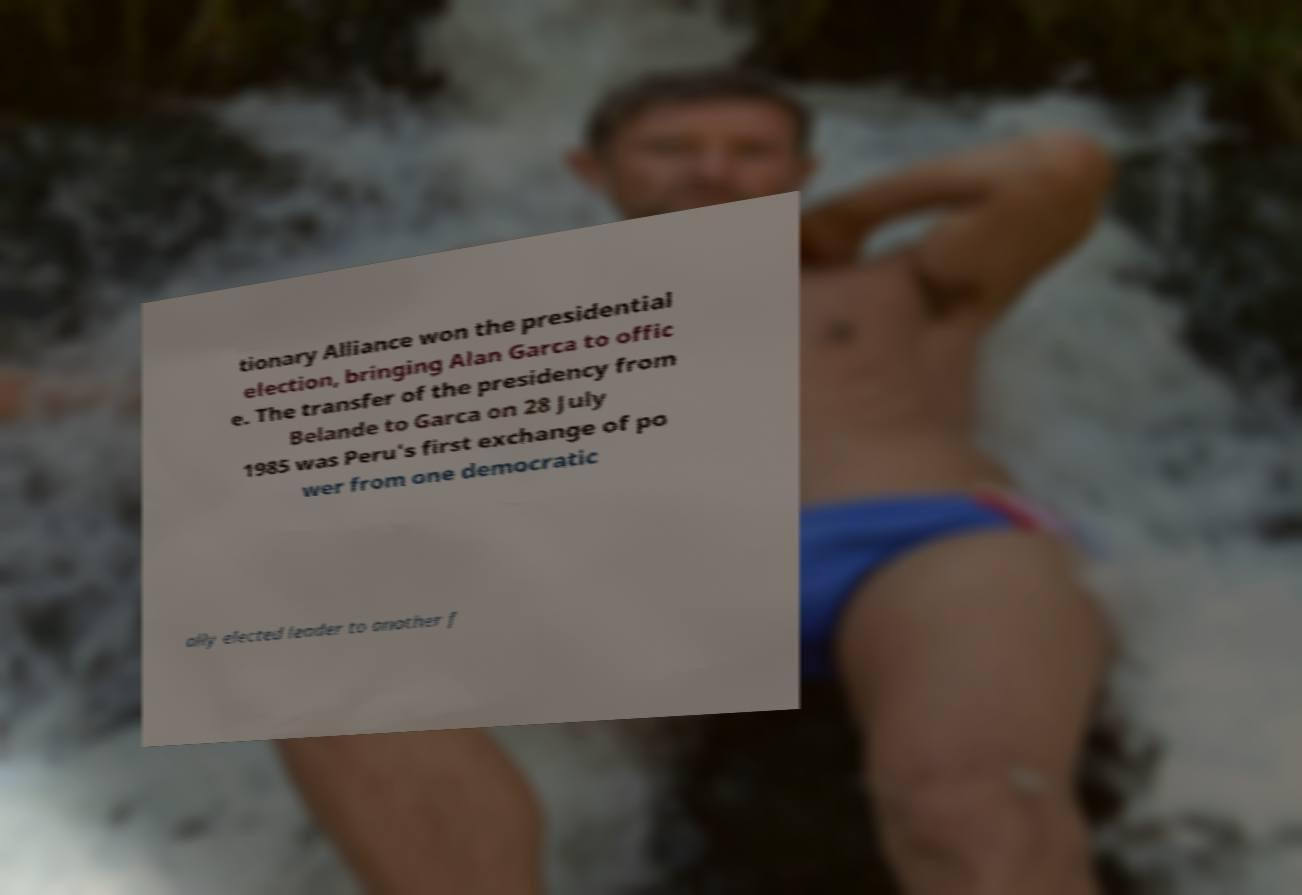Can you accurately transcribe the text from the provided image for me? tionary Alliance won the presidential election, bringing Alan Garca to offic e. The transfer of the presidency from Belande to Garca on 28 July 1985 was Peru's first exchange of po wer from one democratic ally elected leader to another f 